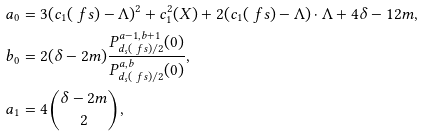Convert formula to latex. <formula><loc_0><loc_0><loc_500><loc_500>a _ { 0 } & = 3 ( c _ { 1 } ( \ f s ) - \Lambda ) ^ { 2 } + c _ { 1 } ^ { 2 } ( X ) + 2 ( c _ { 1 } ( \ f s ) - \Lambda ) \cdot \Lambda + 4 \delta - 1 2 m , \\ b _ { 0 } & = 2 ( \delta - 2 m ) \frac { P ^ { a - 1 , b + 1 } _ { d _ { s } ( \ f s ) / 2 } ( 0 ) } { P ^ { a , b } _ { d _ { s } ( \ f s ) / 2 } ( 0 ) } , \\ a _ { 1 } & = 4 \binom { \delta - 2 m } { 2 } ,</formula> 